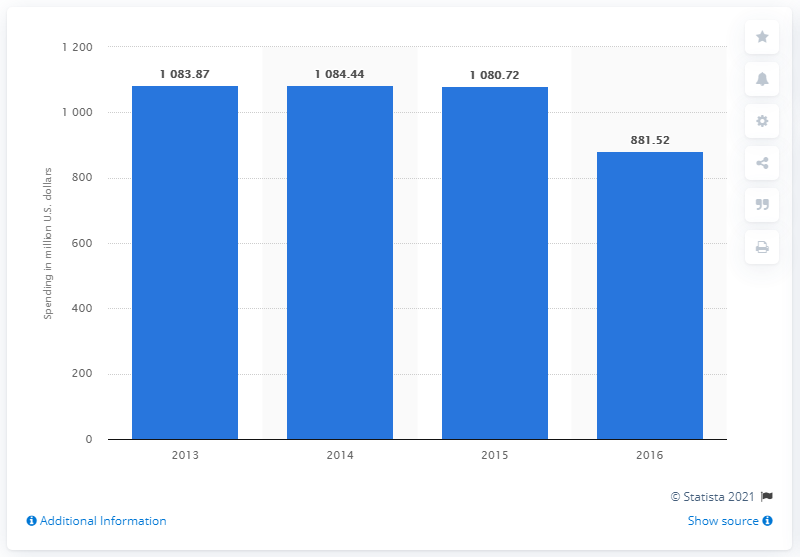Give some essential details in this illustration. In 2016, Yahoo spent approximately 881.52 million dollars on sales and marketing efforts. 